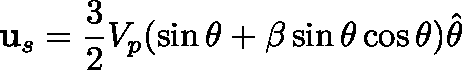<formula> <loc_0><loc_0><loc_500><loc_500>u _ { s } = \frac { 3 } { 2 } V _ { p } ( \sin \theta + \beta \sin \theta \cos \theta ) \hat { \theta }</formula> 